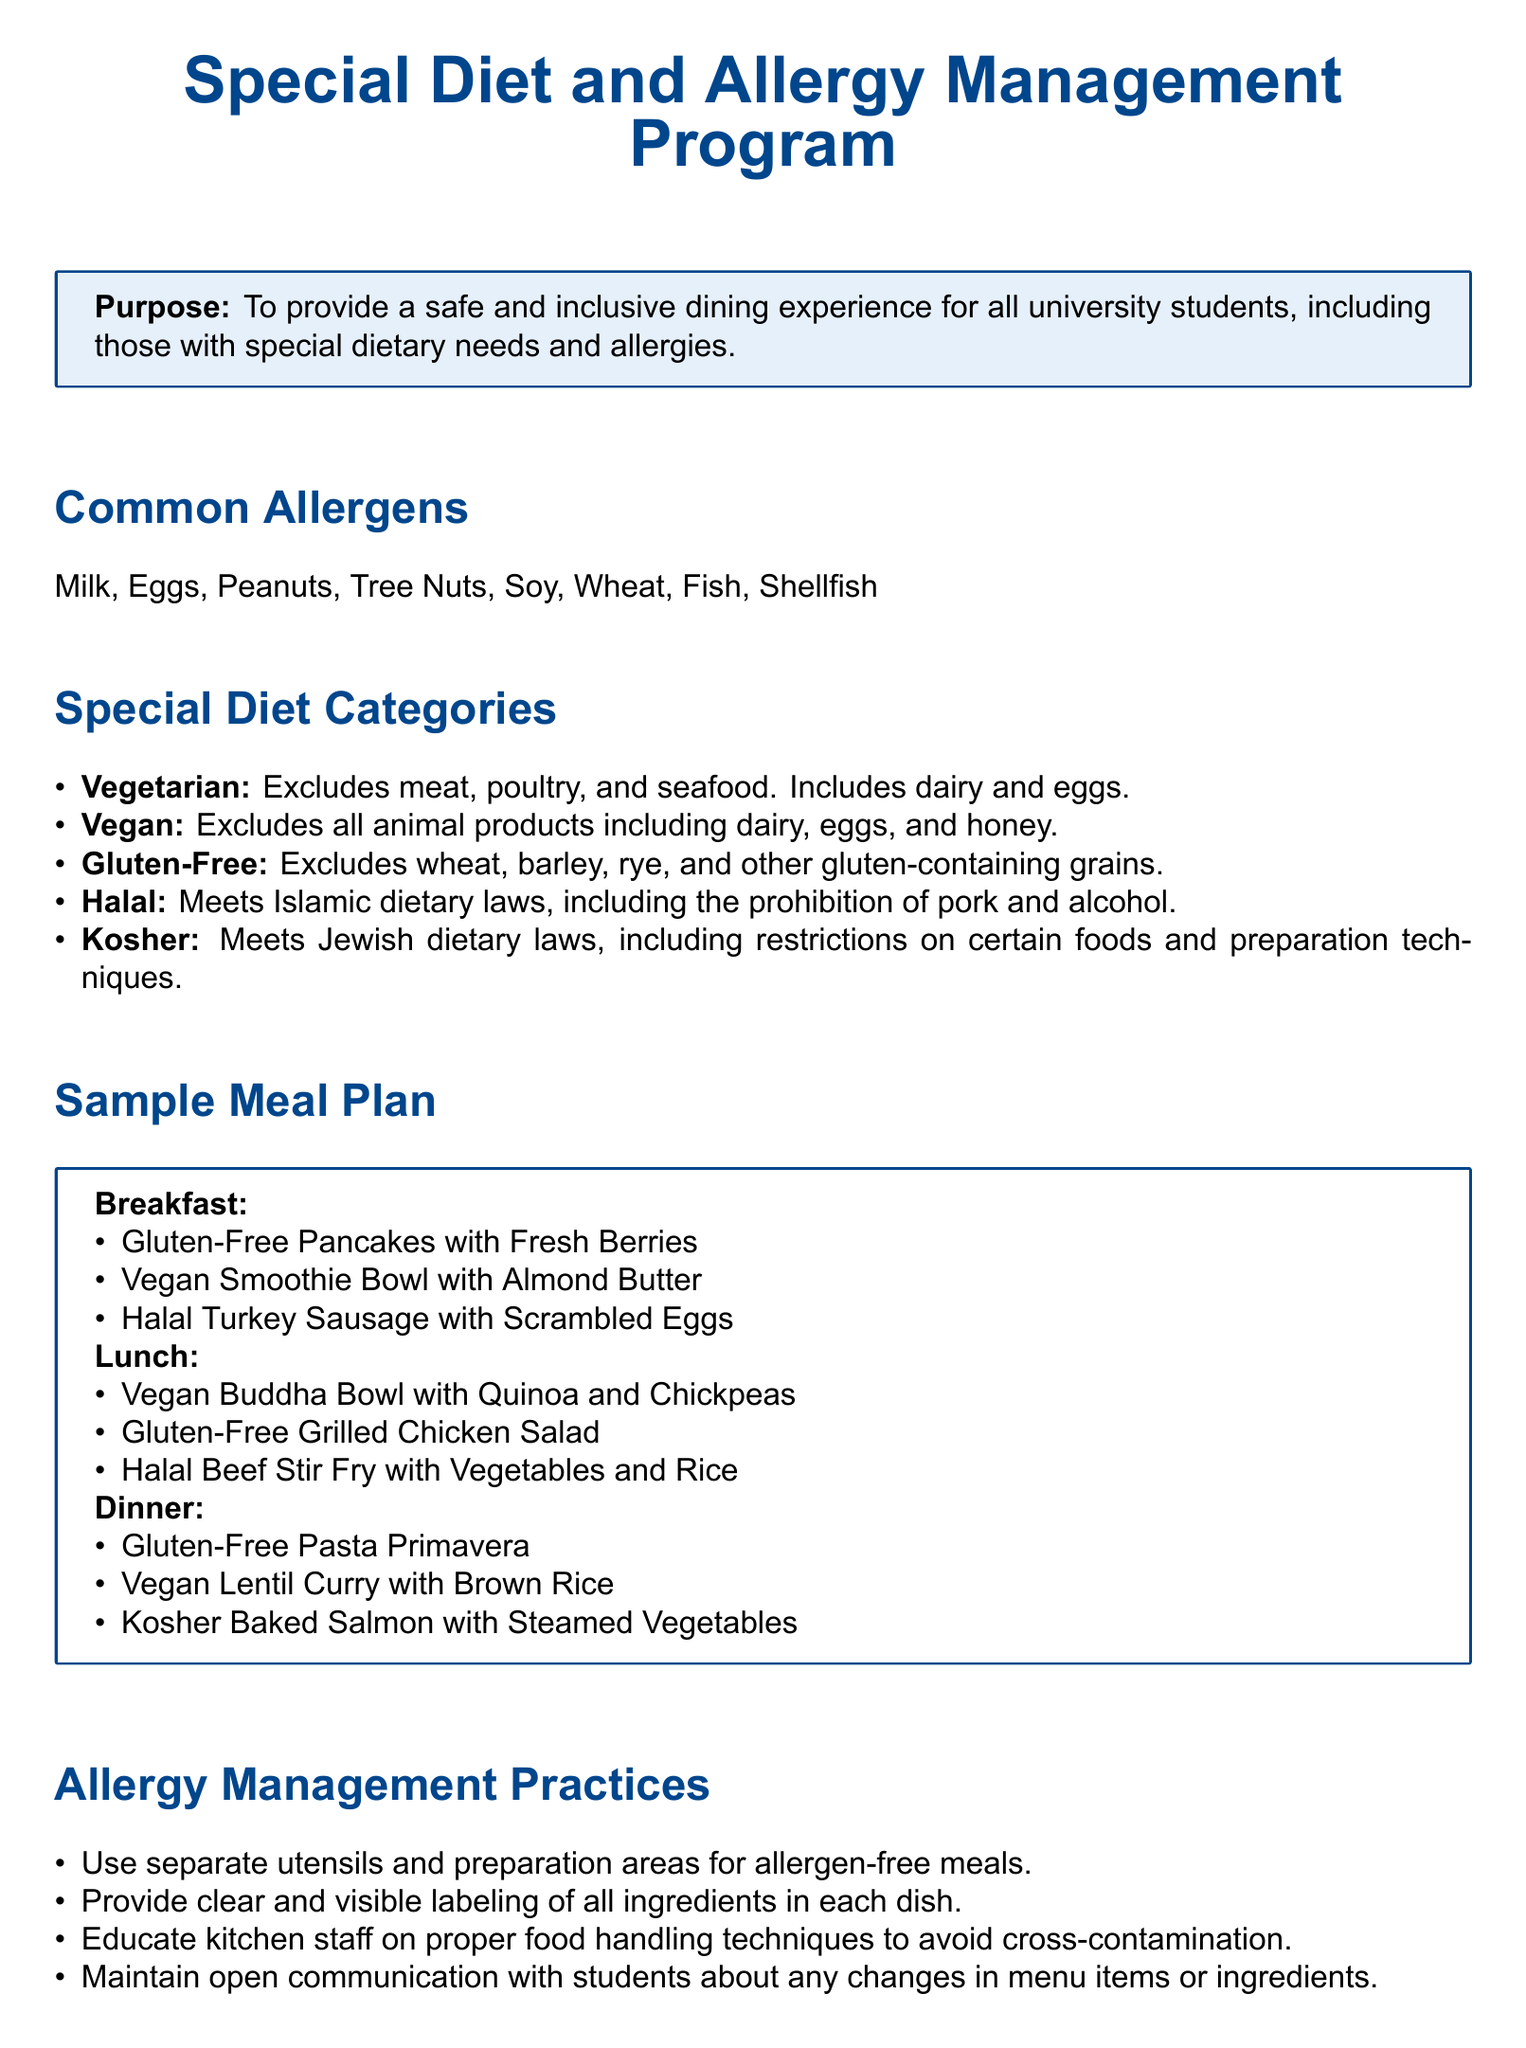What are the common allergens listed? The document specifies the common allergens that need to be managed in the dining program, which include Milk, Eggs, Peanuts, Tree Nuts, Soy, Wheat, Fish, Shellfish.
Answer: Milk, Eggs, Peanuts, Tree Nuts, Soy, Wheat, Fish, Shellfish What is included in the vegetarian diet category? The vegetarian diet category excludes meat, poultry, and seafood but includes dairy and eggs, according to the document.
Answer: Dairy and eggs What meal features a vegan option at breakfast? A vegan option is provided for breakfast in the sample meal plan, highlighting a specific dish that meets vegan criteria.
Answer: Vegan Smoothie Bowl with Almond Butter How many special diet categories are mentioned? The document lists several categories for dietary needs, allowing for easy assessment of the variety offered.
Answer: Five What practice is mentioned for managing food allergies? The document outlines specific practices for ensuring safety related to allergens, focusing on essential methods used to prevent cross-contamination.
Answer: Use separate utensils and preparation areas for allergen-free meals Which meal includes a kosher dish? The sample meal plan specifies dishes for different dietary needs, including one that adheres to kosher dietary laws.
Answer: Kosher Baked Salmon with Steamed Vegetables Who should be contacted for special requests? The contact information suggests a specific department for inquiries or special dietary needs, ensuring students know where to reach out.
Answer: University Dining Services What does the gluten-free diet exclude? The gluten-free diet category details which types of grains are not included, clarifying the restrictions for students following this meal plan.
Answer: Wheat, barley, rye, and other gluten-containing grains 